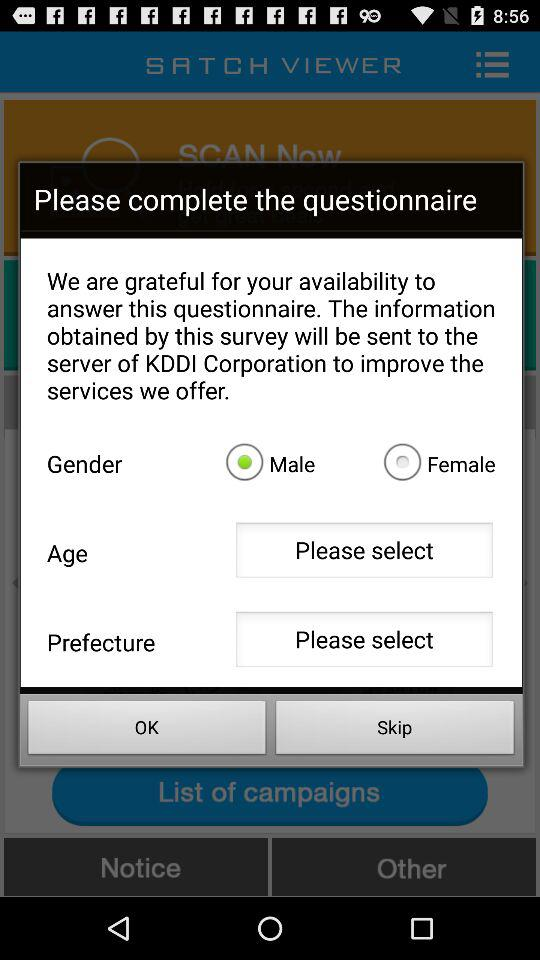What is the selected age?
When the provided information is insufficient, respond with <no answer>. <no answer> 